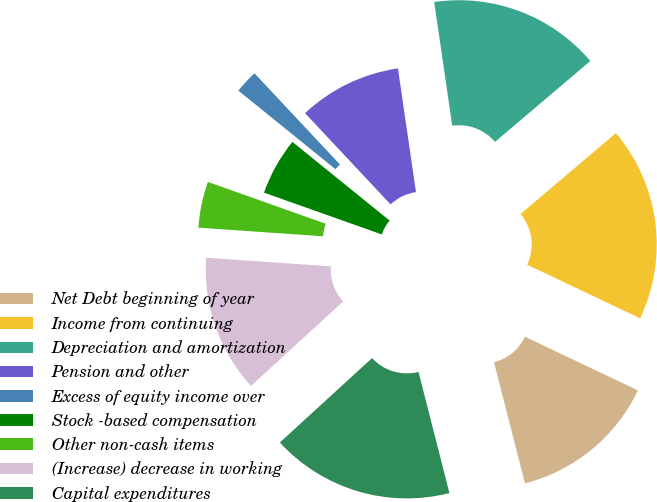<chart> <loc_0><loc_0><loc_500><loc_500><pie_chart><fcel>Net Debt beginning of year<fcel>Income from continuing<fcel>Depreciation and amortization<fcel>Pension and other<fcel>Excess of equity income over<fcel>Stock -based compensation<fcel>Other non-cash items<fcel>(Increase) decrease in working<fcel>Capital expenditures<nl><fcel>13.97%<fcel>18.25%<fcel>16.11%<fcel>9.68%<fcel>2.19%<fcel>5.4%<fcel>4.33%<fcel>12.9%<fcel>17.18%<nl></chart> 